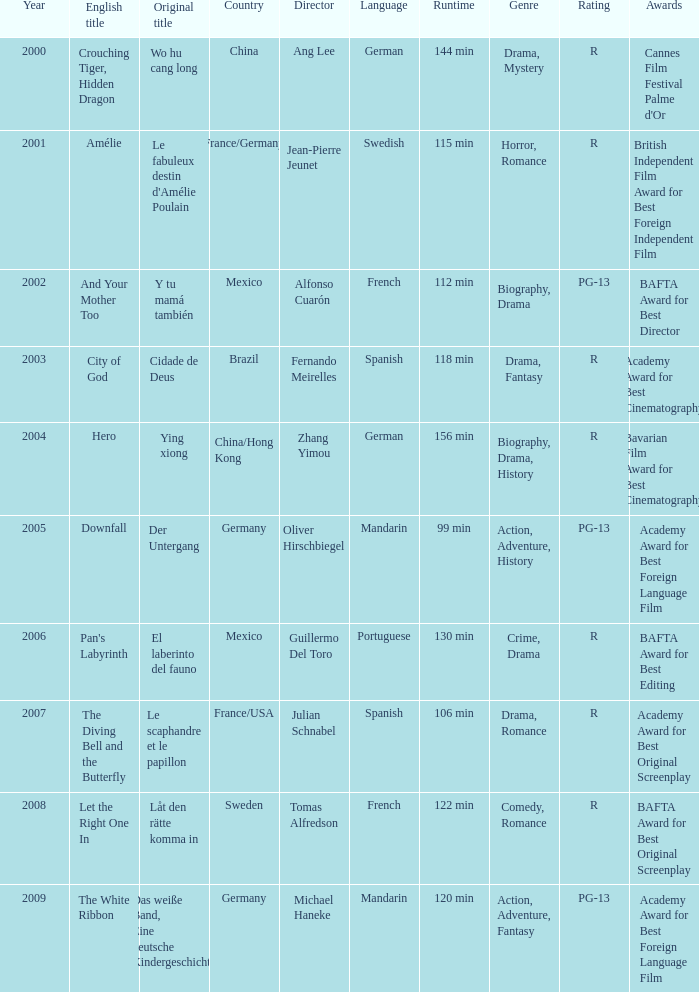Name the title of jean-pierre jeunet Amélie. 